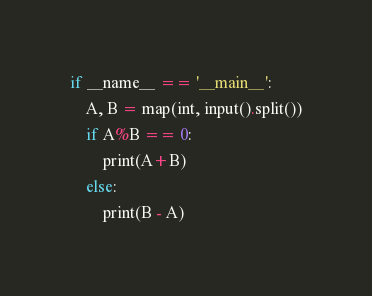Convert code to text. <code><loc_0><loc_0><loc_500><loc_500><_Python_>if __name__ == '__main__':
    A, B = map(int, input().split())
    if A%B == 0:
        print(A+B)
    else:
        print(B - A)</code> 